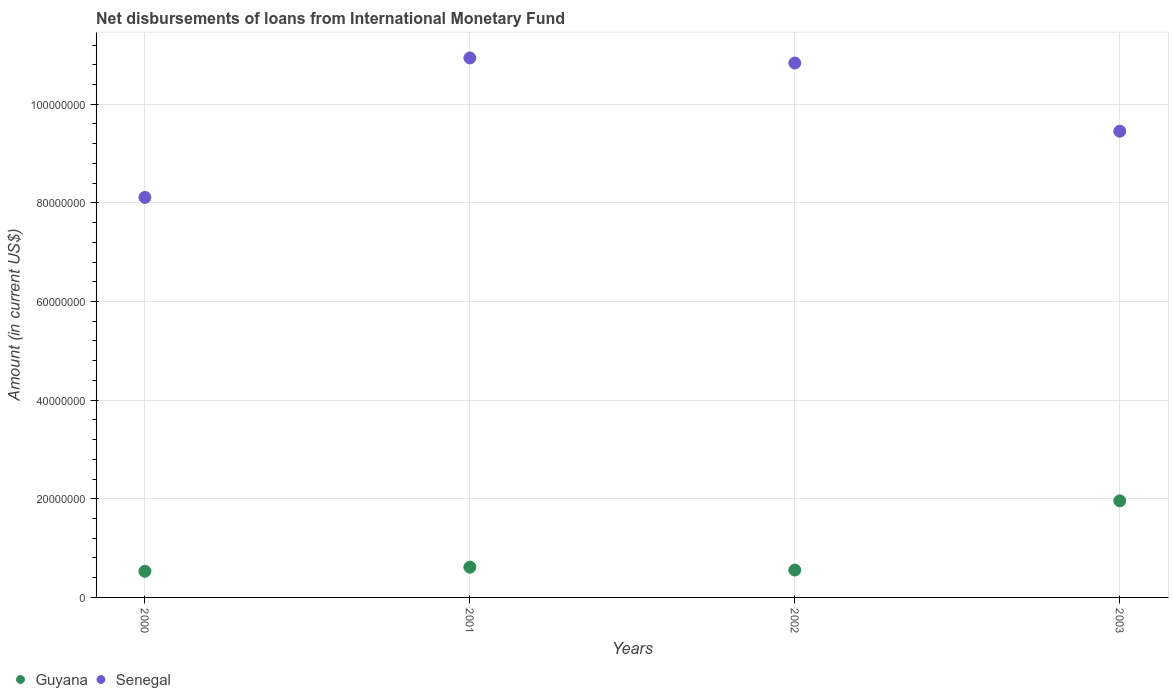How many different coloured dotlines are there?
Offer a very short reply. 2. Is the number of dotlines equal to the number of legend labels?
Your answer should be compact. Yes. What is the amount of loans disbursed in Guyana in 2002?
Give a very brief answer. 5.55e+06. Across all years, what is the maximum amount of loans disbursed in Guyana?
Keep it short and to the point. 1.96e+07. Across all years, what is the minimum amount of loans disbursed in Guyana?
Provide a short and direct response. 5.30e+06. In which year was the amount of loans disbursed in Senegal maximum?
Your answer should be compact. 2001. What is the total amount of loans disbursed in Guyana in the graph?
Make the answer very short. 3.66e+07. What is the difference between the amount of loans disbursed in Senegal in 2001 and that in 2002?
Make the answer very short. 1.03e+06. What is the difference between the amount of loans disbursed in Guyana in 2002 and the amount of loans disbursed in Senegal in 2003?
Your answer should be compact. -8.90e+07. What is the average amount of loans disbursed in Guyana per year?
Ensure brevity in your answer.  9.14e+06. In the year 2001, what is the difference between the amount of loans disbursed in Guyana and amount of loans disbursed in Senegal?
Make the answer very short. -1.03e+08. In how many years, is the amount of loans disbursed in Senegal greater than 72000000 US$?
Provide a short and direct response. 4. What is the ratio of the amount of loans disbursed in Senegal in 2002 to that in 2003?
Provide a short and direct response. 1.15. What is the difference between the highest and the second highest amount of loans disbursed in Senegal?
Make the answer very short. 1.03e+06. What is the difference between the highest and the lowest amount of loans disbursed in Senegal?
Give a very brief answer. 2.83e+07. Is the sum of the amount of loans disbursed in Senegal in 2001 and 2003 greater than the maximum amount of loans disbursed in Guyana across all years?
Make the answer very short. Yes. How many years are there in the graph?
Provide a short and direct response. 4. Are the values on the major ticks of Y-axis written in scientific E-notation?
Give a very brief answer. No. Does the graph contain any zero values?
Provide a succinct answer. No. Where does the legend appear in the graph?
Offer a very short reply. Bottom left. How are the legend labels stacked?
Make the answer very short. Horizontal. What is the title of the graph?
Your response must be concise. Net disbursements of loans from International Monetary Fund. What is the label or title of the X-axis?
Provide a succinct answer. Years. What is the Amount (in current US$) of Guyana in 2000?
Provide a short and direct response. 5.30e+06. What is the Amount (in current US$) in Senegal in 2000?
Provide a short and direct response. 8.11e+07. What is the Amount (in current US$) of Guyana in 2001?
Keep it short and to the point. 6.14e+06. What is the Amount (in current US$) in Senegal in 2001?
Give a very brief answer. 1.09e+08. What is the Amount (in current US$) in Guyana in 2002?
Ensure brevity in your answer.  5.55e+06. What is the Amount (in current US$) in Senegal in 2002?
Your response must be concise. 1.08e+08. What is the Amount (in current US$) of Guyana in 2003?
Give a very brief answer. 1.96e+07. What is the Amount (in current US$) in Senegal in 2003?
Make the answer very short. 9.45e+07. Across all years, what is the maximum Amount (in current US$) in Guyana?
Provide a succinct answer. 1.96e+07. Across all years, what is the maximum Amount (in current US$) of Senegal?
Keep it short and to the point. 1.09e+08. Across all years, what is the minimum Amount (in current US$) of Guyana?
Give a very brief answer. 5.30e+06. Across all years, what is the minimum Amount (in current US$) in Senegal?
Offer a very short reply. 8.11e+07. What is the total Amount (in current US$) in Guyana in the graph?
Give a very brief answer. 3.66e+07. What is the total Amount (in current US$) of Senegal in the graph?
Your answer should be very brief. 3.93e+08. What is the difference between the Amount (in current US$) in Guyana in 2000 and that in 2001?
Your response must be concise. -8.41e+05. What is the difference between the Amount (in current US$) of Senegal in 2000 and that in 2001?
Keep it short and to the point. -2.83e+07. What is the difference between the Amount (in current US$) of Guyana in 2000 and that in 2002?
Keep it short and to the point. -2.57e+05. What is the difference between the Amount (in current US$) of Senegal in 2000 and that in 2002?
Make the answer very short. -2.72e+07. What is the difference between the Amount (in current US$) in Guyana in 2000 and that in 2003?
Your answer should be compact. -1.43e+07. What is the difference between the Amount (in current US$) in Senegal in 2000 and that in 2003?
Offer a terse response. -1.34e+07. What is the difference between the Amount (in current US$) of Guyana in 2001 and that in 2002?
Keep it short and to the point. 5.84e+05. What is the difference between the Amount (in current US$) in Senegal in 2001 and that in 2002?
Offer a very short reply. 1.03e+06. What is the difference between the Amount (in current US$) in Guyana in 2001 and that in 2003?
Your answer should be compact. -1.34e+07. What is the difference between the Amount (in current US$) in Senegal in 2001 and that in 2003?
Provide a succinct answer. 1.49e+07. What is the difference between the Amount (in current US$) in Guyana in 2002 and that in 2003?
Offer a very short reply. -1.40e+07. What is the difference between the Amount (in current US$) in Senegal in 2002 and that in 2003?
Give a very brief answer. 1.38e+07. What is the difference between the Amount (in current US$) of Guyana in 2000 and the Amount (in current US$) of Senegal in 2001?
Your answer should be very brief. -1.04e+08. What is the difference between the Amount (in current US$) of Guyana in 2000 and the Amount (in current US$) of Senegal in 2002?
Your answer should be compact. -1.03e+08. What is the difference between the Amount (in current US$) in Guyana in 2000 and the Amount (in current US$) in Senegal in 2003?
Offer a very short reply. -8.92e+07. What is the difference between the Amount (in current US$) of Guyana in 2001 and the Amount (in current US$) of Senegal in 2002?
Provide a short and direct response. -1.02e+08. What is the difference between the Amount (in current US$) in Guyana in 2001 and the Amount (in current US$) in Senegal in 2003?
Your answer should be very brief. -8.84e+07. What is the difference between the Amount (in current US$) in Guyana in 2002 and the Amount (in current US$) in Senegal in 2003?
Your answer should be compact. -8.90e+07. What is the average Amount (in current US$) in Guyana per year?
Your answer should be very brief. 9.14e+06. What is the average Amount (in current US$) in Senegal per year?
Offer a terse response. 9.83e+07. In the year 2000, what is the difference between the Amount (in current US$) in Guyana and Amount (in current US$) in Senegal?
Offer a very short reply. -7.58e+07. In the year 2001, what is the difference between the Amount (in current US$) of Guyana and Amount (in current US$) of Senegal?
Keep it short and to the point. -1.03e+08. In the year 2002, what is the difference between the Amount (in current US$) of Guyana and Amount (in current US$) of Senegal?
Offer a very short reply. -1.03e+08. In the year 2003, what is the difference between the Amount (in current US$) of Guyana and Amount (in current US$) of Senegal?
Provide a succinct answer. -7.49e+07. What is the ratio of the Amount (in current US$) of Guyana in 2000 to that in 2001?
Provide a succinct answer. 0.86. What is the ratio of the Amount (in current US$) in Senegal in 2000 to that in 2001?
Your answer should be very brief. 0.74. What is the ratio of the Amount (in current US$) in Guyana in 2000 to that in 2002?
Keep it short and to the point. 0.95. What is the ratio of the Amount (in current US$) of Senegal in 2000 to that in 2002?
Offer a terse response. 0.75. What is the ratio of the Amount (in current US$) in Guyana in 2000 to that in 2003?
Offer a very short reply. 0.27. What is the ratio of the Amount (in current US$) in Senegal in 2000 to that in 2003?
Provide a short and direct response. 0.86. What is the ratio of the Amount (in current US$) of Guyana in 2001 to that in 2002?
Your answer should be very brief. 1.11. What is the ratio of the Amount (in current US$) of Senegal in 2001 to that in 2002?
Your answer should be very brief. 1.01. What is the ratio of the Amount (in current US$) in Guyana in 2001 to that in 2003?
Make the answer very short. 0.31. What is the ratio of the Amount (in current US$) in Senegal in 2001 to that in 2003?
Your answer should be compact. 1.16. What is the ratio of the Amount (in current US$) of Guyana in 2002 to that in 2003?
Your response must be concise. 0.28. What is the ratio of the Amount (in current US$) of Senegal in 2002 to that in 2003?
Offer a very short reply. 1.15. What is the difference between the highest and the second highest Amount (in current US$) of Guyana?
Keep it short and to the point. 1.34e+07. What is the difference between the highest and the second highest Amount (in current US$) of Senegal?
Your answer should be very brief. 1.03e+06. What is the difference between the highest and the lowest Amount (in current US$) in Guyana?
Your response must be concise. 1.43e+07. What is the difference between the highest and the lowest Amount (in current US$) of Senegal?
Offer a terse response. 2.83e+07. 